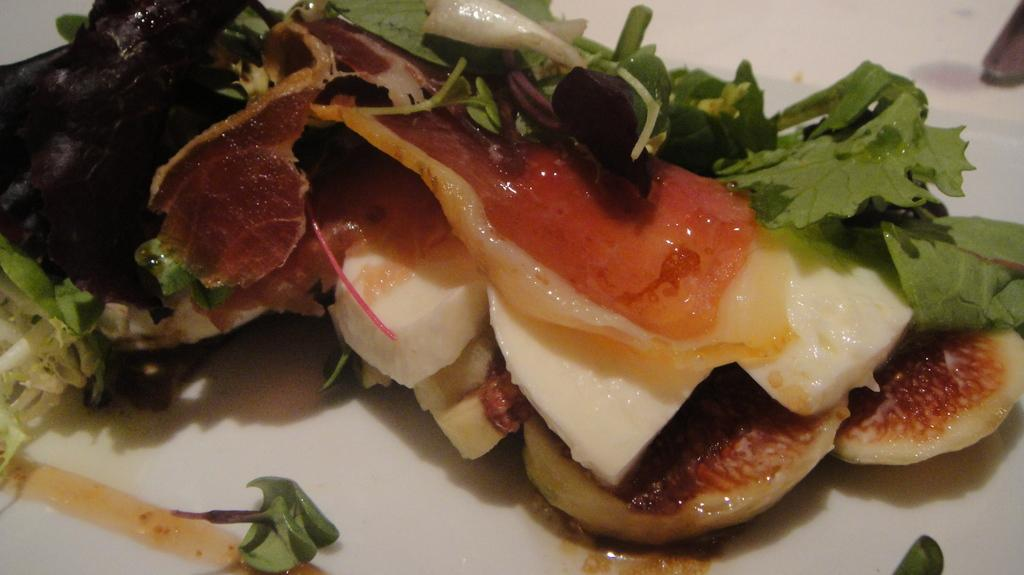What type of items can be seen in the image? There is food and eatable things in the image. What can be inferred about the color of the surface the food and eatable things are on? The surface the food and eatable things are on is white. Can you describe the nature of the food and eatable things in the image? The facts provided do not specify the type of food or eatable things, so we cannot describe their nature. What type of arch can be seen in the image? There is no arch present in the image. What type of chair is visible in the image? There is no chair present in the image. 